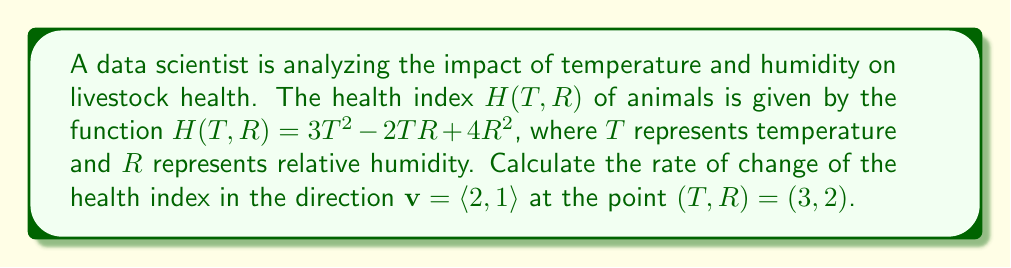Solve this math problem. To solve this problem, we'll use the concept of directional derivative from vector calculus. Here's the step-by-step solution:

1) First, we need to calculate the gradient of $H(T,R)$:
   $$\nabla H = \left\langle \frac{\partial H}{\partial T}, \frac{\partial H}{\partial R} \right\rangle$$

2) Calculate the partial derivatives:
   $$\frac{\partial H}{\partial T} = 6T - 2R$$
   $$\frac{\partial H}{\partial R} = -2T + 8R$$

3) Now we can express the gradient:
   $$\nabla H = \langle 6T - 2R, -2T + 8R \rangle$$

4) Evaluate the gradient at the point $(T,R) = (3,2)$:
   $$\nabla H(3,2) = \langle 6(3) - 2(2), -2(3) + 8(2) \rangle = \langle 14, 10 \rangle$$

5) The directional derivative is given by the dot product of the gradient and the unit vector in the direction of $\mathbf{v}$:
   $$D_\mathbf{v}H = \nabla H \cdot \frac{\mathbf{v}}{|\mathbf{v}|}$$

6) Calculate the magnitude of $\mathbf{v}$:
   $$|\mathbf{v}| = \sqrt{2^2 + 1^2} = \sqrt{5}$$

7) Calculate the unit vector:
   $$\frac{\mathbf{v}}{|\mathbf{v}|} = \left\langle \frac{2}{\sqrt{5}}, \frac{1}{\sqrt{5}} \right\rangle$$

8) Calculate the directional derivative:
   $$D_\mathbf{v}H = \langle 14, 10 \rangle \cdot \left\langle \frac{2}{\sqrt{5}}, \frac{1}{\sqrt{5}} \right\rangle$$
   $$= \frac{14(2) + 10(1)}{\sqrt{5}} = \frac{38}{\sqrt{5}}$$

Therefore, the rate of change of the health index in the direction $\mathbf{v} = \langle 2, 1 \rangle$ at the point $(3,2)$ is $\frac{38}{\sqrt{5}}$.
Answer: $\frac{38}{\sqrt{5}}$ 